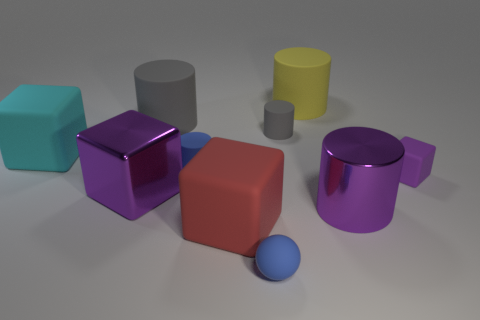Subtract all large purple metal blocks. How many blocks are left? 3 Subtract all blue cylinders. How many cylinders are left? 4 Subtract all purple cylinders. Subtract all cyan balls. How many cylinders are left? 4 Subtract all brown balls. How many blue blocks are left? 0 Subtract all red spheres. Subtract all big matte blocks. How many objects are left? 8 Add 8 small blue rubber objects. How many small blue rubber objects are left? 10 Add 8 large cyan matte cubes. How many large cyan matte cubes exist? 9 Subtract 2 purple cubes. How many objects are left? 8 Subtract all balls. How many objects are left? 9 Subtract 5 cylinders. How many cylinders are left? 0 